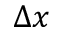<formula> <loc_0><loc_0><loc_500><loc_500>\Delta x</formula> 